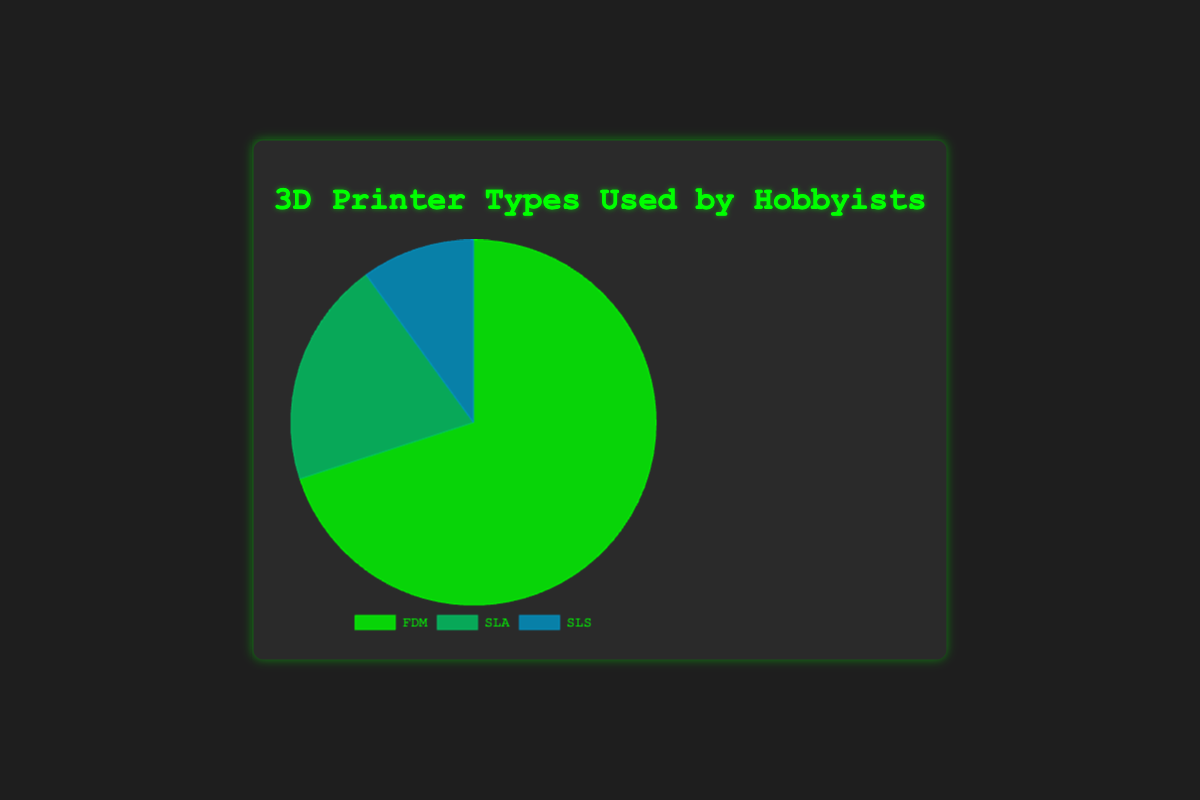What percentage of hobbyists use SLS printers? SLS printers account for 10% of the pie chart representing the usage by hobbyists.
Answer: 10% Which type of 3D printer is the most commonly used by hobbyists? FDM printers hold the largest portion of the pie chart, representing 70% of the total.
Answer: FDM How much more popular are FDM printers than SLA printers? FDM printers are used by 70% of hobbyists, while SLA printers are used by 20%, so the difference is 70% - 20% = 50%.
Answer: 50% What is the combined percentage of hobbyists using SLA and SLS printers? Adding up the percentages for SLA (20%) and SLS (10%) printers, we get 20% + 10% = 30%.
Answer: 30% Which printer type represents the smallest segment in the pie chart? The smallest segment in the pie chart is for SLS printers, which account for 10% of the total.
Answer: SLS If 200 hobbyists were surveyed, how many of them use FDM printers? 70% of 200 hobbyists would be calculated as (70/100) * 200 = 140 hobbyists.
Answer: 140 Comparing FDM printers to the other two types combined, which is more popular? FDM printers are used by 70% of hobbyists, while the combined usage of SLA and SLS (20% + 10% = 30%) is 30%. Thus, FDM is more popular.
Answer: FDM By how much does the usage of SLA printers exceed that of SLS printers? The usage percentage of SLA printers is 20%, and that of SLS printers is 10%. Thus, SLA exceeds SLS by 20% - 10% = 10%.
Answer: 10% What portion of the pie chart is represented by non-FDM printers? Adding up the percentages of SLA (20%) and SLS (10%) gives us a total of 30% for non-FDM printers.
Answer: 30% How would you describe the color associated with SLS printers on the pie chart? SLS printers are depicted in a blue shade on the pie chart.
Answer: blue 